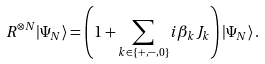<formula> <loc_0><loc_0><loc_500><loc_500>R ^ { \otimes N } | \Psi _ { N } \rangle = \left ( 1 + \sum _ { k \in \{ + , - , 0 \} } i \beta _ { k } J _ { k } \right ) | \Psi _ { N } \rangle \, .</formula> 